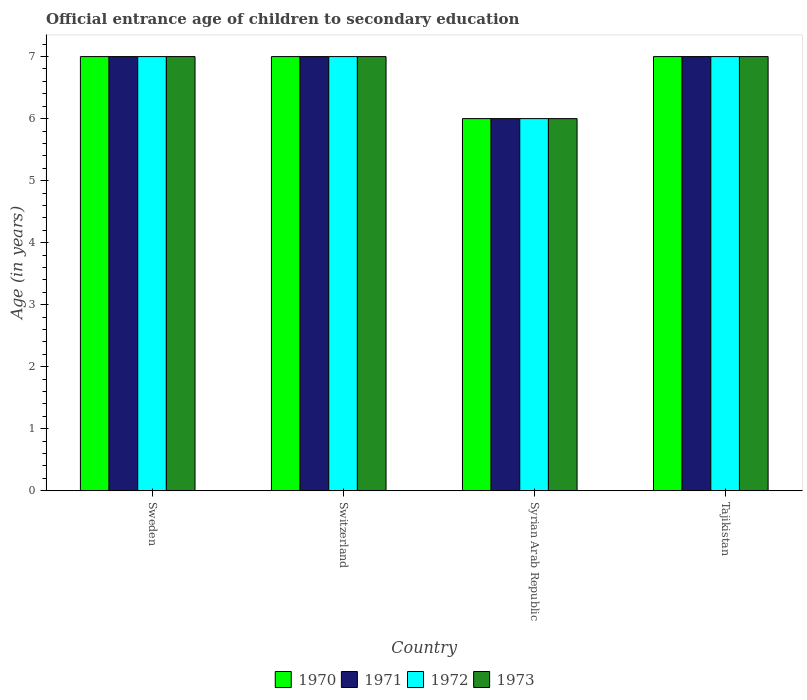How many groups of bars are there?
Ensure brevity in your answer.  4. Are the number of bars per tick equal to the number of legend labels?
Give a very brief answer. Yes. Are the number of bars on each tick of the X-axis equal?
Make the answer very short. Yes. How many bars are there on the 3rd tick from the left?
Make the answer very short. 4. How many bars are there on the 4th tick from the right?
Your answer should be compact. 4. What is the label of the 4th group of bars from the left?
Ensure brevity in your answer.  Tajikistan. Across all countries, what is the maximum secondary school starting age of children in 1970?
Give a very brief answer. 7. Across all countries, what is the minimum secondary school starting age of children in 1970?
Your response must be concise. 6. In which country was the secondary school starting age of children in 1973 minimum?
Provide a short and direct response. Syrian Arab Republic. What is the total secondary school starting age of children in 1971 in the graph?
Ensure brevity in your answer.  27. What is the average secondary school starting age of children in 1971 per country?
Make the answer very short. 6.75. Is the difference between the secondary school starting age of children in 1972 in Sweden and Switzerland greater than the difference between the secondary school starting age of children in 1973 in Sweden and Switzerland?
Your response must be concise. No. What is the difference between the highest and the lowest secondary school starting age of children in 1973?
Offer a very short reply. 1. In how many countries, is the secondary school starting age of children in 1972 greater than the average secondary school starting age of children in 1972 taken over all countries?
Provide a short and direct response. 3. Is it the case that in every country, the sum of the secondary school starting age of children in 1971 and secondary school starting age of children in 1973 is greater than the sum of secondary school starting age of children in 1970 and secondary school starting age of children in 1972?
Provide a short and direct response. No. What does the 3rd bar from the right in Syrian Arab Republic represents?
Offer a very short reply. 1971. Is it the case that in every country, the sum of the secondary school starting age of children in 1970 and secondary school starting age of children in 1973 is greater than the secondary school starting age of children in 1972?
Offer a terse response. Yes. How many countries are there in the graph?
Provide a short and direct response. 4. Are the values on the major ticks of Y-axis written in scientific E-notation?
Your response must be concise. No. Does the graph contain any zero values?
Keep it short and to the point. No. Does the graph contain grids?
Provide a succinct answer. No. Where does the legend appear in the graph?
Ensure brevity in your answer.  Bottom center. How are the legend labels stacked?
Provide a short and direct response. Horizontal. What is the title of the graph?
Your response must be concise. Official entrance age of children to secondary education. What is the label or title of the Y-axis?
Offer a terse response. Age (in years). What is the Age (in years) in 1970 in Sweden?
Provide a short and direct response. 7. What is the Age (in years) of 1972 in Sweden?
Give a very brief answer. 7. What is the Age (in years) of 1970 in Switzerland?
Ensure brevity in your answer.  7. What is the Age (in years) of 1971 in Syrian Arab Republic?
Provide a short and direct response. 6. What is the Age (in years) in 1971 in Tajikistan?
Make the answer very short. 7. What is the Age (in years) in 1972 in Tajikistan?
Provide a succinct answer. 7. Across all countries, what is the maximum Age (in years) of 1970?
Offer a terse response. 7. Across all countries, what is the maximum Age (in years) in 1972?
Make the answer very short. 7. Across all countries, what is the maximum Age (in years) in 1973?
Your response must be concise. 7. Across all countries, what is the minimum Age (in years) of 1971?
Ensure brevity in your answer.  6. Across all countries, what is the minimum Age (in years) of 1973?
Make the answer very short. 6. What is the total Age (in years) in 1973 in the graph?
Make the answer very short. 27. What is the difference between the Age (in years) of 1970 in Sweden and that in Syrian Arab Republic?
Offer a terse response. 1. What is the difference between the Age (in years) of 1971 in Sweden and that in Syrian Arab Republic?
Offer a terse response. 1. What is the difference between the Age (in years) in 1972 in Sweden and that in Syrian Arab Republic?
Provide a short and direct response. 1. What is the difference between the Age (in years) in 1973 in Sweden and that in Syrian Arab Republic?
Make the answer very short. 1. What is the difference between the Age (in years) of 1970 in Sweden and that in Tajikistan?
Provide a succinct answer. 0. What is the difference between the Age (in years) in 1970 in Switzerland and that in Syrian Arab Republic?
Provide a succinct answer. 1. What is the difference between the Age (in years) of 1973 in Switzerland and that in Syrian Arab Republic?
Your response must be concise. 1. What is the difference between the Age (in years) of 1972 in Switzerland and that in Tajikistan?
Make the answer very short. 0. What is the difference between the Age (in years) in 1970 in Syrian Arab Republic and that in Tajikistan?
Provide a short and direct response. -1. What is the difference between the Age (in years) in 1971 in Syrian Arab Republic and that in Tajikistan?
Provide a succinct answer. -1. What is the difference between the Age (in years) in 1972 in Syrian Arab Republic and that in Tajikistan?
Your response must be concise. -1. What is the difference between the Age (in years) in 1970 in Sweden and the Age (in years) in 1971 in Switzerland?
Your response must be concise. 0. What is the difference between the Age (in years) of 1970 in Sweden and the Age (in years) of 1973 in Switzerland?
Give a very brief answer. 0. What is the difference between the Age (in years) of 1970 in Sweden and the Age (in years) of 1971 in Tajikistan?
Your answer should be compact. 0. What is the difference between the Age (in years) in 1972 in Sweden and the Age (in years) in 1973 in Tajikistan?
Your response must be concise. 0. What is the difference between the Age (in years) of 1971 in Switzerland and the Age (in years) of 1973 in Syrian Arab Republic?
Offer a very short reply. 1. What is the difference between the Age (in years) of 1970 in Switzerland and the Age (in years) of 1971 in Tajikistan?
Give a very brief answer. 0. What is the difference between the Age (in years) in 1971 in Switzerland and the Age (in years) in 1972 in Tajikistan?
Give a very brief answer. 0. What is the difference between the Age (in years) of 1970 in Syrian Arab Republic and the Age (in years) of 1971 in Tajikistan?
Provide a short and direct response. -1. What is the difference between the Age (in years) of 1971 in Syrian Arab Republic and the Age (in years) of 1972 in Tajikistan?
Keep it short and to the point. -1. What is the difference between the Age (in years) in 1971 in Syrian Arab Republic and the Age (in years) in 1973 in Tajikistan?
Your answer should be very brief. -1. What is the difference between the Age (in years) of 1972 in Syrian Arab Republic and the Age (in years) of 1973 in Tajikistan?
Your answer should be very brief. -1. What is the average Age (in years) in 1970 per country?
Your answer should be very brief. 6.75. What is the average Age (in years) of 1971 per country?
Your response must be concise. 6.75. What is the average Age (in years) of 1972 per country?
Offer a terse response. 6.75. What is the average Age (in years) of 1973 per country?
Ensure brevity in your answer.  6.75. What is the difference between the Age (in years) in 1970 and Age (in years) in 1972 in Sweden?
Make the answer very short. 0. What is the difference between the Age (in years) in 1970 and Age (in years) in 1973 in Sweden?
Give a very brief answer. 0. What is the difference between the Age (in years) of 1970 and Age (in years) of 1972 in Switzerland?
Offer a very short reply. 0. What is the difference between the Age (in years) in 1970 and Age (in years) in 1973 in Switzerland?
Your answer should be compact. 0. What is the difference between the Age (in years) of 1972 and Age (in years) of 1973 in Switzerland?
Your answer should be compact. 0. What is the difference between the Age (in years) in 1970 and Age (in years) in 1971 in Syrian Arab Republic?
Offer a very short reply. 0. What is the difference between the Age (in years) of 1970 and Age (in years) of 1972 in Syrian Arab Republic?
Offer a very short reply. 0. What is the difference between the Age (in years) of 1970 and Age (in years) of 1973 in Syrian Arab Republic?
Provide a short and direct response. 0. What is the difference between the Age (in years) in 1971 and Age (in years) in 1972 in Syrian Arab Republic?
Offer a terse response. 0. What is the difference between the Age (in years) in 1970 and Age (in years) in 1971 in Tajikistan?
Provide a short and direct response. 0. What is the difference between the Age (in years) in 1970 and Age (in years) in 1972 in Tajikistan?
Offer a terse response. 0. What is the difference between the Age (in years) of 1971 and Age (in years) of 1973 in Tajikistan?
Make the answer very short. 0. What is the difference between the Age (in years) in 1972 and Age (in years) in 1973 in Tajikistan?
Your answer should be compact. 0. What is the ratio of the Age (in years) of 1972 in Sweden to that in Switzerland?
Your response must be concise. 1. What is the ratio of the Age (in years) of 1971 in Sweden to that in Syrian Arab Republic?
Offer a very short reply. 1.17. What is the ratio of the Age (in years) in 1970 in Sweden to that in Tajikistan?
Your response must be concise. 1. What is the ratio of the Age (in years) of 1971 in Sweden to that in Tajikistan?
Keep it short and to the point. 1. What is the ratio of the Age (in years) in 1972 in Sweden to that in Tajikistan?
Keep it short and to the point. 1. What is the ratio of the Age (in years) in 1973 in Sweden to that in Tajikistan?
Offer a terse response. 1. What is the ratio of the Age (in years) of 1970 in Switzerland to that in Syrian Arab Republic?
Make the answer very short. 1.17. What is the ratio of the Age (in years) in 1971 in Switzerland to that in Syrian Arab Republic?
Your response must be concise. 1.17. What is the ratio of the Age (in years) of 1972 in Switzerland to that in Syrian Arab Republic?
Give a very brief answer. 1.17. What is the ratio of the Age (in years) in 1971 in Switzerland to that in Tajikistan?
Your answer should be compact. 1. What is the ratio of the Age (in years) of 1970 in Syrian Arab Republic to that in Tajikistan?
Keep it short and to the point. 0.86. What is the ratio of the Age (in years) of 1971 in Syrian Arab Republic to that in Tajikistan?
Ensure brevity in your answer.  0.86. What is the difference between the highest and the lowest Age (in years) in 1972?
Make the answer very short. 1. What is the difference between the highest and the lowest Age (in years) in 1973?
Give a very brief answer. 1. 